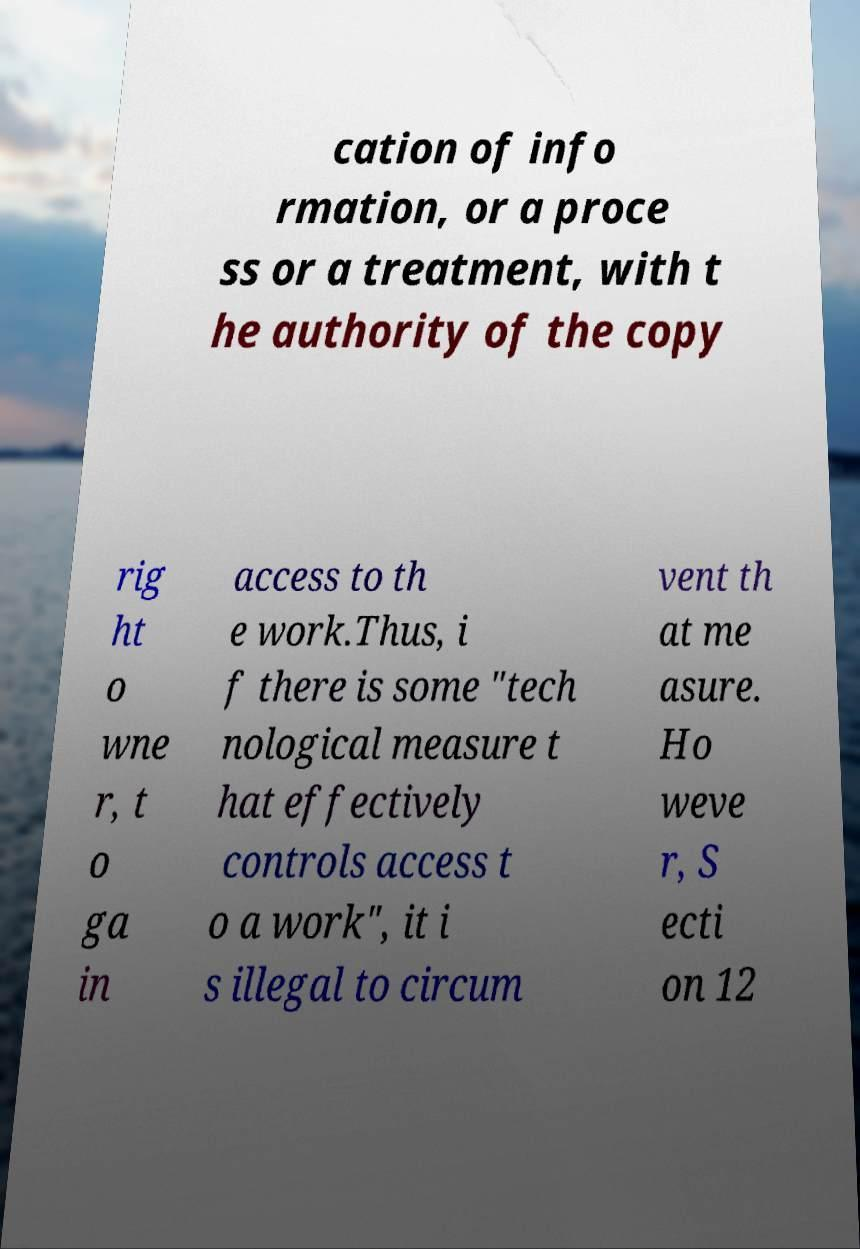I need the written content from this picture converted into text. Can you do that? cation of info rmation, or a proce ss or a treatment, with t he authority of the copy rig ht o wne r, t o ga in access to th e work.Thus, i f there is some "tech nological measure t hat effectively controls access t o a work", it i s illegal to circum vent th at me asure. Ho weve r, S ecti on 12 